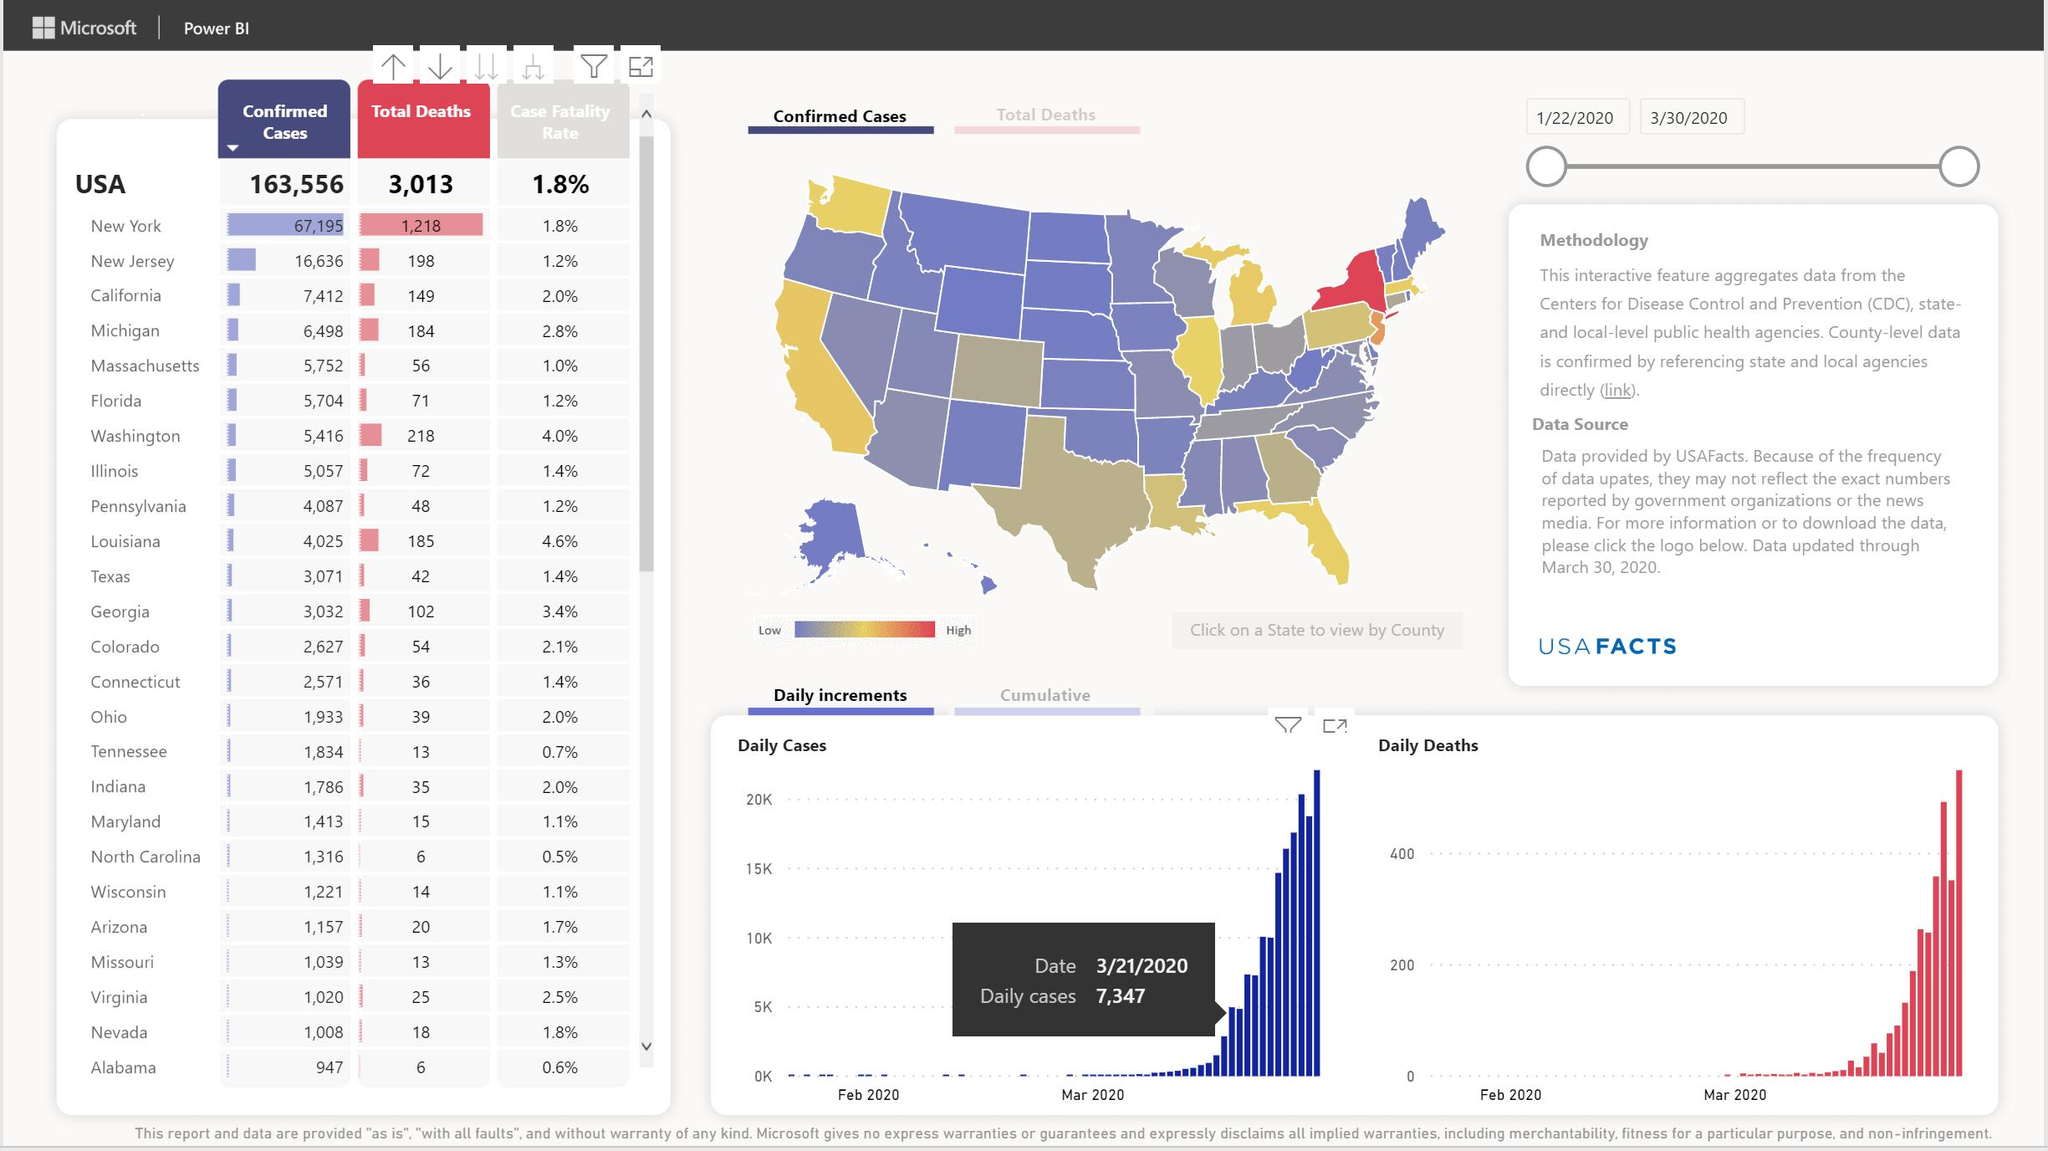List a handful of essential elements in this visual. Alabama and North Carolina have a death count of six. There have been a total of 5,308 confirmed cases of the disease in Pennsylvania and Wisconsin. The case fatality rate of New York and Nevada is the same as that of the United States of America. The total death in New York and New Jersey is 1,416. According to the given information, Alabama, North Carolina, and Tennessee have a case fatality of less than 1%. 